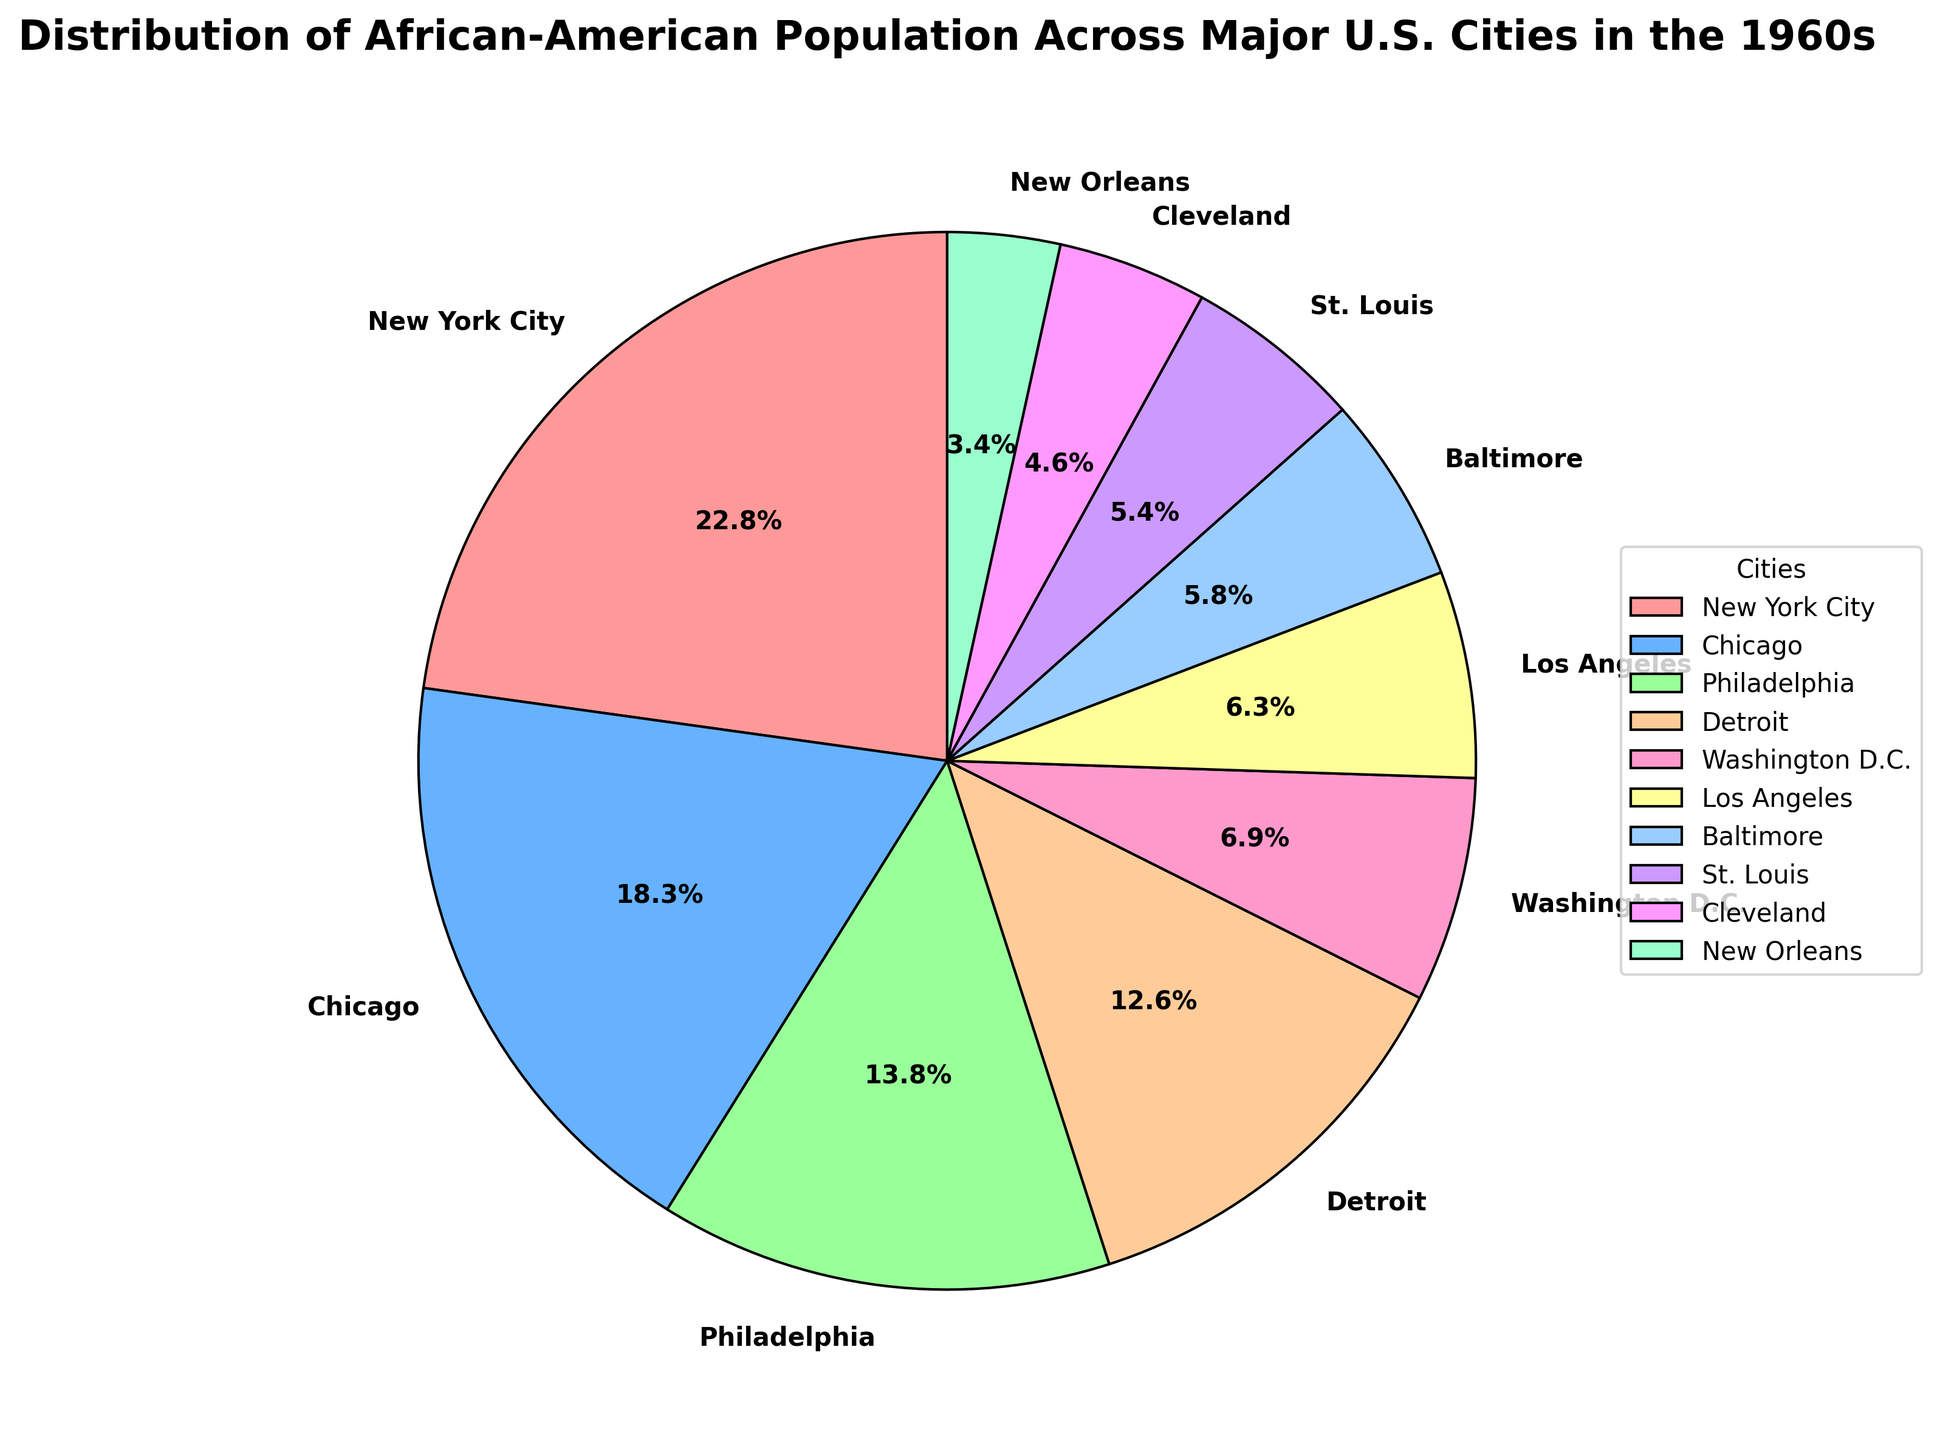What percentage of the African-American population lived in New York City? The pie chart indicates the percentage of the African-American population in various cities. The percentage for New York City is shown in the segment labeled "New York City".
Answer: 28.5% Which city had a higher percentage of the African-American population, Chicago or Philadelphia? To answer this, compare the percentages associated with Chicago and Philadelphia. Chicago has 22.9%, while Philadelphia has 17.3%.
Answer: Chicago What is the combined percentage of the African-American population in New York City, Chicago, and Philadelphia? The percentages for New York City, Chicago, and Philadelphia are 28.5%, 22.9%, and 17.3%, respectively. Adding them yields 28.5 + 22.9 + 17.3 = 68.7%.
Answer: 68.7% How much larger is the African-American population percentage in Detroit compared to Los Angeles? Detroit has 15.8%, and Los Angeles has 7.9%. Subtract the smaller percentage from the larger one: 15.8 - 7.9 = 7.9%.
Answer: 7.9% Which city among Baltimore, St. Louis, and Cleveland has the smallest African-American population percentage? The segments for Baltimore, St. Louis, and Cleveland show percentages of 7.2%, 6.8%, and 5.7%, respectively. Cleveland has the smallest percentage.
Answer: Cleveland If you combine the percentages for Baltimore and New Orleans, do they exceed the percentage of Washington D.C.? Baltimore has 7.2%, and New Orleans has 4.3%. Combined, they give 7.2 + 4.3 = 11.5%, which is greater than Washington D.C.'s 8.6%.
Answer: Yes What is the total percentage of the African-American population in cities with less than 10% each? The cities with less than 10% each are Washington D.C. (8.6%), Los Angeles (7.9%), Baltimore (7.2%), St. Louis (6.8%), Cleveland (5.7%), and New Orleans (4.3%). Summing these percentages: 8.6 + 7.9 + 7.2 + 6.8 + 5.7 + 4.3 = 40.5%.
Answer: 40.5% How does the percentage of the African-American population in Philadelphia compare to that in Washington D.C.? Philadelphia has 17.3% and Washington D.C. has 8.6%. Since 17.3% is greater than 8.6%, Philadelphia has a larger percentage.
Answer: Philadelphia has a larger percentage Which color corresponds to New Orleans, and what is its percentage? Identify the color assigned to New Orleans in the pie chart and note its percentage from the chart's segment labels. The color is not specified directly in text but can be visually identified from the given colors list; here, its percentage is 4.3%.
Answer: The visually identified color for New Orleans and 4.3% What is the difference in the African-American population percentage between the highest and the lowest represented cities? The highest percentage is in New York City (28.5%), and the lowest is in New Orleans (4.3%). Subtract the smallest from the largest: 28.5 - 4.3 = 24.2%.
Answer: 24.2% 